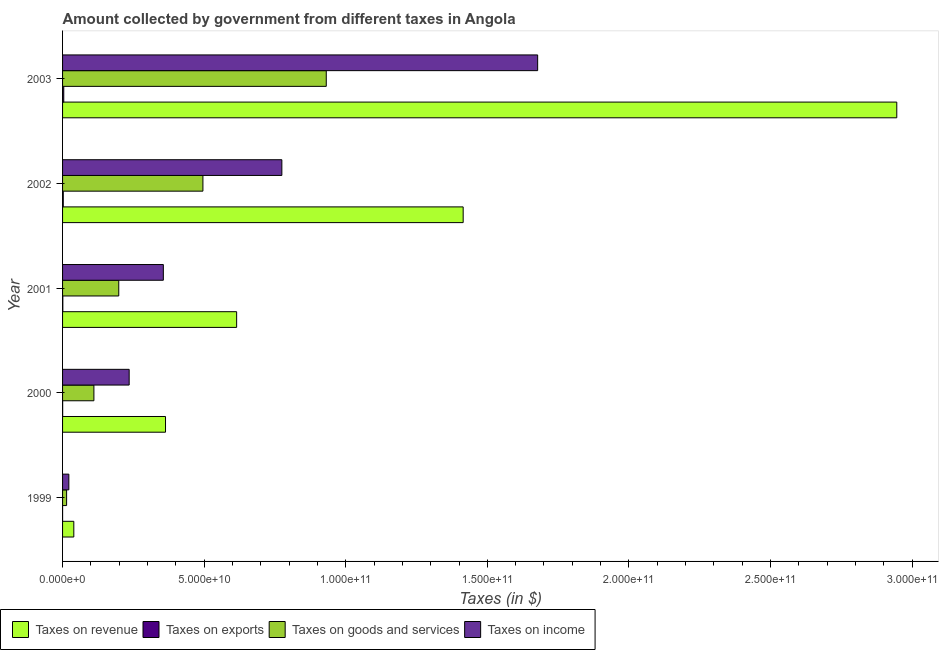How many groups of bars are there?
Make the answer very short. 5. How many bars are there on the 3rd tick from the top?
Your answer should be compact. 4. What is the amount collected as tax on income in 1999?
Ensure brevity in your answer.  2.22e+09. Across all years, what is the maximum amount collected as tax on goods?
Provide a succinct answer. 9.31e+1. Across all years, what is the minimum amount collected as tax on exports?
Provide a short and direct response. 3.22e+06. In which year was the amount collected as tax on revenue maximum?
Your response must be concise. 2003. In which year was the amount collected as tax on revenue minimum?
Your response must be concise. 1999. What is the total amount collected as tax on exports in the graph?
Offer a very short reply. 8.01e+08. What is the difference between the amount collected as tax on goods in 2000 and that in 2003?
Give a very brief answer. -8.21e+1. What is the difference between the amount collected as tax on exports in 2003 and the amount collected as tax on income in 2001?
Your answer should be very brief. -3.52e+1. What is the average amount collected as tax on goods per year?
Provide a short and direct response. 3.50e+1. In the year 1999, what is the difference between the amount collected as tax on revenue and amount collected as tax on income?
Your answer should be compact. 1.75e+09. What is the ratio of the amount collected as tax on income in 2001 to that in 2003?
Offer a very short reply. 0.21. Is the amount collected as tax on income in 1999 less than that in 2000?
Your response must be concise. Yes. What is the difference between the highest and the second highest amount collected as tax on exports?
Give a very brief answer. 1.75e+08. What is the difference between the highest and the lowest amount collected as tax on exports?
Your answer should be very brief. 4.20e+08. In how many years, is the amount collected as tax on goods greater than the average amount collected as tax on goods taken over all years?
Ensure brevity in your answer.  2. Is the sum of the amount collected as tax on revenue in 2000 and 2003 greater than the maximum amount collected as tax on goods across all years?
Ensure brevity in your answer.  Yes. Is it the case that in every year, the sum of the amount collected as tax on revenue and amount collected as tax on exports is greater than the sum of amount collected as tax on income and amount collected as tax on goods?
Your answer should be compact. No. What does the 2nd bar from the top in 2001 represents?
Make the answer very short. Taxes on goods and services. What does the 4th bar from the bottom in 2003 represents?
Give a very brief answer. Taxes on income. Is it the case that in every year, the sum of the amount collected as tax on revenue and amount collected as tax on exports is greater than the amount collected as tax on goods?
Your answer should be very brief. Yes. How many bars are there?
Ensure brevity in your answer.  20. Does the graph contain any zero values?
Your answer should be compact. No. Does the graph contain grids?
Your answer should be very brief. No. Where does the legend appear in the graph?
Your response must be concise. Bottom left. How many legend labels are there?
Make the answer very short. 4. What is the title of the graph?
Ensure brevity in your answer.  Amount collected by government from different taxes in Angola. What is the label or title of the X-axis?
Give a very brief answer. Taxes (in $). What is the Taxes (in $) in Taxes on revenue in 1999?
Offer a very short reply. 3.97e+09. What is the Taxes (in $) in Taxes on exports in 1999?
Your response must be concise. 3.22e+06. What is the Taxes (in $) of Taxes on goods and services in 1999?
Offer a terse response. 1.43e+09. What is the Taxes (in $) in Taxes on income in 1999?
Provide a short and direct response. 2.22e+09. What is the Taxes (in $) in Taxes on revenue in 2000?
Keep it short and to the point. 3.64e+1. What is the Taxes (in $) in Taxes on exports in 2000?
Offer a very short reply. 3.43e+07. What is the Taxes (in $) of Taxes on goods and services in 2000?
Offer a very short reply. 1.11e+1. What is the Taxes (in $) of Taxes on income in 2000?
Provide a succinct answer. 2.35e+1. What is the Taxes (in $) of Taxes on revenue in 2001?
Your answer should be compact. 6.15e+1. What is the Taxes (in $) of Taxes on exports in 2001?
Offer a very short reply. 9.21e+07. What is the Taxes (in $) of Taxes on goods and services in 2001?
Your answer should be very brief. 1.98e+1. What is the Taxes (in $) in Taxes on income in 2001?
Provide a short and direct response. 3.56e+1. What is the Taxes (in $) in Taxes on revenue in 2002?
Keep it short and to the point. 1.41e+11. What is the Taxes (in $) in Taxes on exports in 2002?
Your answer should be compact. 2.48e+08. What is the Taxes (in $) in Taxes on goods and services in 2002?
Your answer should be compact. 4.96e+1. What is the Taxes (in $) of Taxes on income in 2002?
Offer a very short reply. 7.74e+1. What is the Taxes (in $) in Taxes on revenue in 2003?
Give a very brief answer. 2.95e+11. What is the Taxes (in $) in Taxes on exports in 2003?
Offer a terse response. 4.24e+08. What is the Taxes (in $) in Taxes on goods and services in 2003?
Provide a short and direct response. 9.31e+1. What is the Taxes (in $) of Taxes on income in 2003?
Make the answer very short. 1.68e+11. Across all years, what is the maximum Taxes (in $) in Taxes on revenue?
Offer a very short reply. 2.95e+11. Across all years, what is the maximum Taxes (in $) in Taxes on exports?
Your answer should be very brief. 4.24e+08. Across all years, what is the maximum Taxes (in $) in Taxes on goods and services?
Give a very brief answer. 9.31e+1. Across all years, what is the maximum Taxes (in $) of Taxes on income?
Offer a terse response. 1.68e+11. Across all years, what is the minimum Taxes (in $) of Taxes on revenue?
Keep it short and to the point. 3.97e+09. Across all years, what is the minimum Taxes (in $) in Taxes on exports?
Provide a short and direct response. 3.22e+06. Across all years, what is the minimum Taxes (in $) in Taxes on goods and services?
Your answer should be very brief. 1.43e+09. Across all years, what is the minimum Taxes (in $) in Taxes on income?
Make the answer very short. 2.22e+09. What is the total Taxes (in $) in Taxes on revenue in the graph?
Your response must be concise. 5.38e+11. What is the total Taxes (in $) of Taxes on exports in the graph?
Provide a succinct answer. 8.01e+08. What is the total Taxes (in $) of Taxes on goods and services in the graph?
Provide a short and direct response. 1.75e+11. What is the total Taxes (in $) in Taxes on income in the graph?
Make the answer very short. 3.07e+11. What is the difference between the Taxes (in $) in Taxes on revenue in 1999 and that in 2000?
Provide a succinct answer. -3.24e+1. What is the difference between the Taxes (in $) in Taxes on exports in 1999 and that in 2000?
Offer a terse response. -3.10e+07. What is the difference between the Taxes (in $) of Taxes on goods and services in 1999 and that in 2000?
Your answer should be compact. -9.64e+09. What is the difference between the Taxes (in $) of Taxes on income in 1999 and that in 2000?
Make the answer very short. -2.13e+1. What is the difference between the Taxes (in $) in Taxes on revenue in 1999 and that in 2001?
Keep it short and to the point. -5.75e+1. What is the difference between the Taxes (in $) in Taxes on exports in 1999 and that in 2001?
Your response must be concise. -8.88e+07. What is the difference between the Taxes (in $) in Taxes on goods and services in 1999 and that in 2001?
Your response must be concise. -1.84e+1. What is the difference between the Taxes (in $) in Taxes on income in 1999 and that in 2001?
Keep it short and to the point. -3.34e+1. What is the difference between the Taxes (in $) of Taxes on revenue in 1999 and that in 2002?
Provide a succinct answer. -1.38e+11. What is the difference between the Taxes (in $) in Taxes on exports in 1999 and that in 2002?
Offer a very short reply. -2.45e+08. What is the difference between the Taxes (in $) of Taxes on goods and services in 1999 and that in 2002?
Give a very brief answer. -4.81e+1. What is the difference between the Taxes (in $) of Taxes on income in 1999 and that in 2002?
Offer a very short reply. -7.52e+1. What is the difference between the Taxes (in $) in Taxes on revenue in 1999 and that in 2003?
Your response must be concise. -2.91e+11. What is the difference between the Taxes (in $) of Taxes on exports in 1999 and that in 2003?
Give a very brief answer. -4.20e+08. What is the difference between the Taxes (in $) in Taxes on goods and services in 1999 and that in 2003?
Offer a terse response. -9.17e+1. What is the difference between the Taxes (in $) in Taxes on income in 1999 and that in 2003?
Make the answer very short. -1.66e+11. What is the difference between the Taxes (in $) in Taxes on revenue in 2000 and that in 2001?
Keep it short and to the point. -2.51e+1. What is the difference between the Taxes (in $) in Taxes on exports in 2000 and that in 2001?
Your answer should be very brief. -5.78e+07. What is the difference between the Taxes (in $) in Taxes on goods and services in 2000 and that in 2001?
Offer a very short reply. -8.78e+09. What is the difference between the Taxes (in $) of Taxes on income in 2000 and that in 2001?
Your answer should be very brief. -1.21e+1. What is the difference between the Taxes (in $) in Taxes on revenue in 2000 and that in 2002?
Make the answer very short. -1.05e+11. What is the difference between the Taxes (in $) in Taxes on exports in 2000 and that in 2002?
Offer a very short reply. -2.14e+08. What is the difference between the Taxes (in $) in Taxes on goods and services in 2000 and that in 2002?
Ensure brevity in your answer.  -3.85e+1. What is the difference between the Taxes (in $) of Taxes on income in 2000 and that in 2002?
Provide a short and direct response. -5.39e+1. What is the difference between the Taxes (in $) in Taxes on revenue in 2000 and that in 2003?
Ensure brevity in your answer.  -2.58e+11. What is the difference between the Taxes (in $) of Taxes on exports in 2000 and that in 2003?
Your answer should be compact. -3.89e+08. What is the difference between the Taxes (in $) in Taxes on goods and services in 2000 and that in 2003?
Ensure brevity in your answer.  -8.21e+1. What is the difference between the Taxes (in $) in Taxes on income in 2000 and that in 2003?
Offer a very short reply. -1.44e+11. What is the difference between the Taxes (in $) of Taxes on revenue in 2001 and that in 2002?
Make the answer very short. -8.00e+1. What is the difference between the Taxes (in $) in Taxes on exports in 2001 and that in 2002?
Your answer should be very brief. -1.56e+08. What is the difference between the Taxes (in $) in Taxes on goods and services in 2001 and that in 2002?
Give a very brief answer. -2.97e+1. What is the difference between the Taxes (in $) in Taxes on income in 2001 and that in 2002?
Keep it short and to the point. -4.19e+1. What is the difference between the Taxes (in $) of Taxes on revenue in 2001 and that in 2003?
Ensure brevity in your answer.  -2.33e+11. What is the difference between the Taxes (in $) of Taxes on exports in 2001 and that in 2003?
Give a very brief answer. -3.32e+08. What is the difference between the Taxes (in $) in Taxes on goods and services in 2001 and that in 2003?
Your answer should be very brief. -7.33e+1. What is the difference between the Taxes (in $) of Taxes on income in 2001 and that in 2003?
Your response must be concise. -1.32e+11. What is the difference between the Taxes (in $) in Taxes on revenue in 2002 and that in 2003?
Make the answer very short. -1.53e+11. What is the difference between the Taxes (in $) in Taxes on exports in 2002 and that in 2003?
Your answer should be compact. -1.75e+08. What is the difference between the Taxes (in $) in Taxes on goods and services in 2002 and that in 2003?
Give a very brief answer. -4.36e+1. What is the difference between the Taxes (in $) in Taxes on income in 2002 and that in 2003?
Offer a very short reply. -9.03e+1. What is the difference between the Taxes (in $) in Taxes on revenue in 1999 and the Taxes (in $) in Taxes on exports in 2000?
Offer a very short reply. 3.94e+09. What is the difference between the Taxes (in $) of Taxes on revenue in 1999 and the Taxes (in $) of Taxes on goods and services in 2000?
Ensure brevity in your answer.  -7.10e+09. What is the difference between the Taxes (in $) in Taxes on revenue in 1999 and the Taxes (in $) in Taxes on income in 2000?
Keep it short and to the point. -1.96e+1. What is the difference between the Taxes (in $) of Taxes on exports in 1999 and the Taxes (in $) of Taxes on goods and services in 2000?
Offer a very short reply. -1.11e+1. What is the difference between the Taxes (in $) in Taxes on exports in 1999 and the Taxes (in $) in Taxes on income in 2000?
Ensure brevity in your answer.  -2.35e+1. What is the difference between the Taxes (in $) of Taxes on goods and services in 1999 and the Taxes (in $) of Taxes on income in 2000?
Provide a succinct answer. -2.21e+1. What is the difference between the Taxes (in $) in Taxes on revenue in 1999 and the Taxes (in $) in Taxes on exports in 2001?
Your answer should be compact. 3.88e+09. What is the difference between the Taxes (in $) in Taxes on revenue in 1999 and the Taxes (in $) in Taxes on goods and services in 2001?
Your answer should be compact. -1.59e+1. What is the difference between the Taxes (in $) in Taxes on revenue in 1999 and the Taxes (in $) in Taxes on income in 2001?
Provide a succinct answer. -3.16e+1. What is the difference between the Taxes (in $) of Taxes on exports in 1999 and the Taxes (in $) of Taxes on goods and services in 2001?
Your answer should be compact. -1.98e+1. What is the difference between the Taxes (in $) in Taxes on exports in 1999 and the Taxes (in $) in Taxes on income in 2001?
Your answer should be compact. -3.56e+1. What is the difference between the Taxes (in $) of Taxes on goods and services in 1999 and the Taxes (in $) of Taxes on income in 2001?
Provide a succinct answer. -3.42e+1. What is the difference between the Taxes (in $) of Taxes on revenue in 1999 and the Taxes (in $) of Taxes on exports in 2002?
Keep it short and to the point. 3.72e+09. What is the difference between the Taxes (in $) of Taxes on revenue in 1999 and the Taxes (in $) of Taxes on goods and services in 2002?
Offer a very short reply. -4.56e+1. What is the difference between the Taxes (in $) of Taxes on revenue in 1999 and the Taxes (in $) of Taxes on income in 2002?
Provide a short and direct response. -7.35e+1. What is the difference between the Taxes (in $) in Taxes on exports in 1999 and the Taxes (in $) in Taxes on goods and services in 2002?
Ensure brevity in your answer.  -4.96e+1. What is the difference between the Taxes (in $) in Taxes on exports in 1999 and the Taxes (in $) in Taxes on income in 2002?
Your answer should be very brief. -7.74e+1. What is the difference between the Taxes (in $) in Taxes on goods and services in 1999 and the Taxes (in $) in Taxes on income in 2002?
Offer a very short reply. -7.60e+1. What is the difference between the Taxes (in $) of Taxes on revenue in 1999 and the Taxes (in $) of Taxes on exports in 2003?
Offer a terse response. 3.55e+09. What is the difference between the Taxes (in $) of Taxes on revenue in 1999 and the Taxes (in $) of Taxes on goods and services in 2003?
Give a very brief answer. -8.92e+1. What is the difference between the Taxes (in $) in Taxes on revenue in 1999 and the Taxes (in $) in Taxes on income in 2003?
Make the answer very short. -1.64e+11. What is the difference between the Taxes (in $) of Taxes on exports in 1999 and the Taxes (in $) of Taxes on goods and services in 2003?
Keep it short and to the point. -9.31e+1. What is the difference between the Taxes (in $) of Taxes on exports in 1999 and the Taxes (in $) of Taxes on income in 2003?
Provide a short and direct response. -1.68e+11. What is the difference between the Taxes (in $) in Taxes on goods and services in 1999 and the Taxes (in $) in Taxes on income in 2003?
Provide a succinct answer. -1.66e+11. What is the difference between the Taxes (in $) in Taxes on revenue in 2000 and the Taxes (in $) in Taxes on exports in 2001?
Your answer should be compact. 3.63e+1. What is the difference between the Taxes (in $) of Taxes on revenue in 2000 and the Taxes (in $) of Taxes on goods and services in 2001?
Offer a very short reply. 1.65e+1. What is the difference between the Taxes (in $) in Taxes on revenue in 2000 and the Taxes (in $) in Taxes on income in 2001?
Your answer should be compact. 7.67e+08. What is the difference between the Taxes (in $) of Taxes on exports in 2000 and the Taxes (in $) of Taxes on goods and services in 2001?
Give a very brief answer. -1.98e+1. What is the difference between the Taxes (in $) in Taxes on exports in 2000 and the Taxes (in $) in Taxes on income in 2001?
Make the answer very short. -3.56e+1. What is the difference between the Taxes (in $) in Taxes on goods and services in 2000 and the Taxes (in $) in Taxes on income in 2001?
Provide a succinct answer. -2.45e+1. What is the difference between the Taxes (in $) of Taxes on revenue in 2000 and the Taxes (in $) of Taxes on exports in 2002?
Provide a short and direct response. 3.61e+1. What is the difference between the Taxes (in $) in Taxes on revenue in 2000 and the Taxes (in $) in Taxes on goods and services in 2002?
Your answer should be very brief. -1.32e+1. What is the difference between the Taxes (in $) of Taxes on revenue in 2000 and the Taxes (in $) of Taxes on income in 2002?
Make the answer very short. -4.11e+1. What is the difference between the Taxes (in $) in Taxes on exports in 2000 and the Taxes (in $) in Taxes on goods and services in 2002?
Provide a short and direct response. -4.95e+1. What is the difference between the Taxes (in $) in Taxes on exports in 2000 and the Taxes (in $) in Taxes on income in 2002?
Your response must be concise. -7.74e+1. What is the difference between the Taxes (in $) of Taxes on goods and services in 2000 and the Taxes (in $) of Taxes on income in 2002?
Offer a very short reply. -6.64e+1. What is the difference between the Taxes (in $) in Taxes on revenue in 2000 and the Taxes (in $) in Taxes on exports in 2003?
Your answer should be very brief. 3.59e+1. What is the difference between the Taxes (in $) of Taxes on revenue in 2000 and the Taxes (in $) of Taxes on goods and services in 2003?
Keep it short and to the point. -5.68e+1. What is the difference between the Taxes (in $) in Taxes on revenue in 2000 and the Taxes (in $) in Taxes on income in 2003?
Give a very brief answer. -1.31e+11. What is the difference between the Taxes (in $) of Taxes on exports in 2000 and the Taxes (in $) of Taxes on goods and services in 2003?
Your answer should be compact. -9.31e+1. What is the difference between the Taxes (in $) in Taxes on exports in 2000 and the Taxes (in $) in Taxes on income in 2003?
Your answer should be compact. -1.68e+11. What is the difference between the Taxes (in $) of Taxes on goods and services in 2000 and the Taxes (in $) of Taxes on income in 2003?
Your answer should be compact. -1.57e+11. What is the difference between the Taxes (in $) of Taxes on revenue in 2001 and the Taxes (in $) of Taxes on exports in 2002?
Offer a terse response. 6.12e+1. What is the difference between the Taxes (in $) of Taxes on revenue in 2001 and the Taxes (in $) of Taxes on goods and services in 2002?
Your answer should be compact. 1.19e+1. What is the difference between the Taxes (in $) of Taxes on revenue in 2001 and the Taxes (in $) of Taxes on income in 2002?
Offer a terse response. -1.60e+1. What is the difference between the Taxes (in $) of Taxes on exports in 2001 and the Taxes (in $) of Taxes on goods and services in 2002?
Give a very brief answer. -4.95e+1. What is the difference between the Taxes (in $) of Taxes on exports in 2001 and the Taxes (in $) of Taxes on income in 2002?
Give a very brief answer. -7.73e+1. What is the difference between the Taxes (in $) of Taxes on goods and services in 2001 and the Taxes (in $) of Taxes on income in 2002?
Ensure brevity in your answer.  -5.76e+1. What is the difference between the Taxes (in $) of Taxes on revenue in 2001 and the Taxes (in $) of Taxes on exports in 2003?
Provide a succinct answer. 6.11e+1. What is the difference between the Taxes (in $) of Taxes on revenue in 2001 and the Taxes (in $) of Taxes on goods and services in 2003?
Make the answer very short. -3.16e+1. What is the difference between the Taxes (in $) in Taxes on revenue in 2001 and the Taxes (in $) in Taxes on income in 2003?
Provide a succinct answer. -1.06e+11. What is the difference between the Taxes (in $) in Taxes on exports in 2001 and the Taxes (in $) in Taxes on goods and services in 2003?
Make the answer very short. -9.30e+1. What is the difference between the Taxes (in $) in Taxes on exports in 2001 and the Taxes (in $) in Taxes on income in 2003?
Keep it short and to the point. -1.68e+11. What is the difference between the Taxes (in $) in Taxes on goods and services in 2001 and the Taxes (in $) in Taxes on income in 2003?
Offer a very short reply. -1.48e+11. What is the difference between the Taxes (in $) of Taxes on revenue in 2002 and the Taxes (in $) of Taxes on exports in 2003?
Your answer should be compact. 1.41e+11. What is the difference between the Taxes (in $) of Taxes on revenue in 2002 and the Taxes (in $) of Taxes on goods and services in 2003?
Offer a terse response. 4.83e+1. What is the difference between the Taxes (in $) in Taxes on revenue in 2002 and the Taxes (in $) in Taxes on income in 2003?
Keep it short and to the point. -2.63e+1. What is the difference between the Taxes (in $) of Taxes on exports in 2002 and the Taxes (in $) of Taxes on goods and services in 2003?
Your answer should be very brief. -9.29e+1. What is the difference between the Taxes (in $) of Taxes on exports in 2002 and the Taxes (in $) of Taxes on income in 2003?
Keep it short and to the point. -1.68e+11. What is the difference between the Taxes (in $) of Taxes on goods and services in 2002 and the Taxes (in $) of Taxes on income in 2003?
Give a very brief answer. -1.18e+11. What is the average Taxes (in $) in Taxes on revenue per year?
Provide a short and direct response. 1.08e+11. What is the average Taxes (in $) of Taxes on exports per year?
Make the answer very short. 1.60e+08. What is the average Taxes (in $) of Taxes on goods and services per year?
Your answer should be compact. 3.50e+1. What is the average Taxes (in $) in Taxes on income per year?
Keep it short and to the point. 6.13e+1. In the year 1999, what is the difference between the Taxes (in $) in Taxes on revenue and Taxes (in $) in Taxes on exports?
Offer a terse response. 3.97e+09. In the year 1999, what is the difference between the Taxes (in $) in Taxes on revenue and Taxes (in $) in Taxes on goods and services?
Offer a very short reply. 2.54e+09. In the year 1999, what is the difference between the Taxes (in $) in Taxes on revenue and Taxes (in $) in Taxes on income?
Provide a succinct answer. 1.75e+09. In the year 1999, what is the difference between the Taxes (in $) in Taxes on exports and Taxes (in $) in Taxes on goods and services?
Offer a terse response. -1.42e+09. In the year 1999, what is the difference between the Taxes (in $) in Taxes on exports and Taxes (in $) in Taxes on income?
Ensure brevity in your answer.  -2.22e+09. In the year 1999, what is the difference between the Taxes (in $) of Taxes on goods and services and Taxes (in $) of Taxes on income?
Offer a terse response. -7.93e+08. In the year 2000, what is the difference between the Taxes (in $) of Taxes on revenue and Taxes (in $) of Taxes on exports?
Provide a short and direct response. 3.63e+1. In the year 2000, what is the difference between the Taxes (in $) of Taxes on revenue and Taxes (in $) of Taxes on goods and services?
Give a very brief answer. 2.53e+1. In the year 2000, what is the difference between the Taxes (in $) of Taxes on revenue and Taxes (in $) of Taxes on income?
Your response must be concise. 1.28e+1. In the year 2000, what is the difference between the Taxes (in $) in Taxes on exports and Taxes (in $) in Taxes on goods and services?
Give a very brief answer. -1.10e+1. In the year 2000, what is the difference between the Taxes (in $) in Taxes on exports and Taxes (in $) in Taxes on income?
Offer a terse response. -2.35e+1. In the year 2000, what is the difference between the Taxes (in $) of Taxes on goods and services and Taxes (in $) of Taxes on income?
Provide a short and direct response. -1.25e+1. In the year 2001, what is the difference between the Taxes (in $) in Taxes on revenue and Taxes (in $) in Taxes on exports?
Ensure brevity in your answer.  6.14e+1. In the year 2001, what is the difference between the Taxes (in $) of Taxes on revenue and Taxes (in $) of Taxes on goods and services?
Provide a short and direct response. 4.16e+1. In the year 2001, what is the difference between the Taxes (in $) in Taxes on revenue and Taxes (in $) in Taxes on income?
Keep it short and to the point. 2.59e+1. In the year 2001, what is the difference between the Taxes (in $) of Taxes on exports and Taxes (in $) of Taxes on goods and services?
Ensure brevity in your answer.  -1.98e+1. In the year 2001, what is the difference between the Taxes (in $) in Taxes on exports and Taxes (in $) in Taxes on income?
Give a very brief answer. -3.55e+1. In the year 2001, what is the difference between the Taxes (in $) of Taxes on goods and services and Taxes (in $) of Taxes on income?
Give a very brief answer. -1.57e+1. In the year 2002, what is the difference between the Taxes (in $) in Taxes on revenue and Taxes (in $) in Taxes on exports?
Offer a terse response. 1.41e+11. In the year 2002, what is the difference between the Taxes (in $) of Taxes on revenue and Taxes (in $) of Taxes on goods and services?
Make the answer very short. 9.19e+1. In the year 2002, what is the difference between the Taxes (in $) in Taxes on revenue and Taxes (in $) in Taxes on income?
Provide a succinct answer. 6.40e+1. In the year 2002, what is the difference between the Taxes (in $) in Taxes on exports and Taxes (in $) in Taxes on goods and services?
Your answer should be compact. -4.93e+1. In the year 2002, what is the difference between the Taxes (in $) of Taxes on exports and Taxes (in $) of Taxes on income?
Ensure brevity in your answer.  -7.72e+1. In the year 2002, what is the difference between the Taxes (in $) in Taxes on goods and services and Taxes (in $) in Taxes on income?
Provide a succinct answer. -2.79e+1. In the year 2003, what is the difference between the Taxes (in $) of Taxes on revenue and Taxes (in $) of Taxes on exports?
Make the answer very short. 2.94e+11. In the year 2003, what is the difference between the Taxes (in $) in Taxes on revenue and Taxes (in $) in Taxes on goods and services?
Make the answer very short. 2.01e+11. In the year 2003, what is the difference between the Taxes (in $) of Taxes on revenue and Taxes (in $) of Taxes on income?
Make the answer very short. 1.27e+11. In the year 2003, what is the difference between the Taxes (in $) in Taxes on exports and Taxes (in $) in Taxes on goods and services?
Offer a very short reply. -9.27e+1. In the year 2003, what is the difference between the Taxes (in $) in Taxes on exports and Taxes (in $) in Taxes on income?
Provide a short and direct response. -1.67e+11. In the year 2003, what is the difference between the Taxes (in $) of Taxes on goods and services and Taxes (in $) of Taxes on income?
Your response must be concise. -7.46e+1. What is the ratio of the Taxes (in $) in Taxes on revenue in 1999 to that in 2000?
Offer a very short reply. 0.11. What is the ratio of the Taxes (in $) in Taxes on exports in 1999 to that in 2000?
Make the answer very short. 0.09. What is the ratio of the Taxes (in $) in Taxes on goods and services in 1999 to that in 2000?
Make the answer very short. 0.13. What is the ratio of the Taxes (in $) of Taxes on income in 1999 to that in 2000?
Offer a very short reply. 0.09. What is the ratio of the Taxes (in $) of Taxes on revenue in 1999 to that in 2001?
Your answer should be compact. 0.06. What is the ratio of the Taxes (in $) in Taxes on exports in 1999 to that in 2001?
Offer a terse response. 0.04. What is the ratio of the Taxes (in $) of Taxes on goods and services in 1999 to that in 2001?
Make the answer very short. 0.07. What is the ratio of the Taxes (in $) in Taxes on income in 1999 to that in 2001?
Your answer should be compact. 0.06. What is the ratio of the Taxes (in $) in Taxes on revenue in 1999 to that in 2002?
Make the answer very short. 0.03. What is the ratio of the Taxes (in $) in Taxes on exports in 1999 to that in 2002?
Keep it short and to the point. 0.01. What is the ratio of the Taxes (in $) in Taxes on goods and services in 1999 to that in 2002?
Keep it short and to the point. 0.03. What is the ratio of the Taxes (in $) of Taxes on income in 1999 to that in 2002?
Give a very brief answer. 0.03. What is the ratio of the Taxes (in $) in Taxes on revenue in 1999 to that in 2003?
Your answer should be compact. 0.01. What is the ratio of the Taxes (in $) in Taxes on exports in 1999 to that in 2003?
Offer a terse response. 0.01. What is the ratio of the Taxes (in $) of Taxes on goods and services in 1999 to that in 2003?
Offer a very short reply. 0.02. What is the ratio of the Taxes (in $) of Taxes on income in 1999 to that in 2003?
Give a very brief answer. 0.01. What is the ratio of the Taxes (in $) in Taxes on revenue in 2000 to that in 2001?
Keep it short and to the point. 0.59. What is the ratio of the Taxes (in $) of Taxes on exports in 2000 to that in 2001?
Your answer should be compact. 0.37. What is the ratio of the Taxes (in $) in Taxes on goods and services in 2000 to that in 2001?
Give a very brief answer. 0.56. What is the ratio of the Taxes (in $) in Taxes on income in 2000 to that in 2001?
Make the answer very short. 0.66. What is the ratio of the Taxes (in $) of Taxes on revenue in 2000 to that in 2002?
Give a very brief answer. 0.26. What is the ratio of the Taxes (in $) in Taxes on exports in 2000 to that in 2002?
Your response must be concise. 0.14. What is the ratio of the Taxes (in $) of Taxes on goods and services in 2000 to that in 2002?
Make the answer very short. 0.22. What is the ratio of the Taxes (in $) of Taxes on income in 2000 to that in 2002?
Your answer should be compact. 0.3. What is the ratio of the Taxes (in $) of Taxes on revenue in 2000 to that in 2003?
Offer a very short reply. 0.12. What is the ratio of the Taxes (in $) of Taxes on exports in 2000 to that in 2003?
Provide a succinct answer. 0.08. What is the ratio of the Taxes (in $) of Taxes on goods and services in 2000 to that in 2003?
Offer a very short reply. 0.12. What is the ratio of the Taxes (in $) in Taxes on income in 2000 to that in 2003?
Provide a succinct answer. 0.14. What is the ratio of the Taxes (in $) in Taxes on revenue in 2001 to that in 2002?
Provide a succinct answer. 0.43. What is the ratio of the Taxes (in $) in Taxes on exports in 2001 to that in 2002?
Make the answer very short. 0.37. What is the ratio of the Taxes (in $) of Taxes on goods and services in 2001 to that in 2002?
Keep it short and to the point. 0.4. What is the ratio of the Taxes (in $) of Taxes on income in 2001 to that in 2002?
Make the answer very short. 0.46. What is the ratio of the Taxes (in $) of Taxes on revenue in 2001 to that in 2003?
Provide a succinct answer. 0.21. What is the ratio of the Taxes (in $) of Taxes on exports in 2001 to that in 2003?
Offer a terse response. 0.22. What is the ratio of the Taxes (in $) in Taxes on goods and services in 2001 to that in 2003?
Make the answer very short. 0.21. What is the ratio of the Taxes (in $) in Taxes on income in 2001 to that in 2003?
Your response must be concise. 0.21. What is the ratio of the Taxes (in $) in Taxes on revenue in 2002 to that in 2003?
Offer a very short reply. 0.48. What is the ratio of the Taxes (in $) in Taxes on exports in 2002 to that in 2003?
Your response must be concise. 0.59. What is the ratio of the Taxes (in $) in Taxes on goods and services in 2002 to that in 2003?
Your answer should be very brief. 0.53. What is the ratio of the Taxes (in $) in Taxes on income in 2002 to that in 2003?
Your answer should be compact. 0.46. What is the difference between the highest and the second highest Taxes (in $) of Taxes on revenue?
Your response must be concise. 1.53e+11. What is the difference between the highest and the second highest Taxes (in $) in Taxes on exports?
Give a very brief answer. 1.75e+08. What is the difference between the highest and the second highest Taxes (in $) of Taxes on goods and services?
Provide a succinct answer. 4.36e+1. What is the difference between the highest and the second highest Taxes (in $) in Taxes on income?
Give a very brief answer. 9.03e+1. What is the difference between the highest and the lowest Taxes (in $) in Taxes on revenue?
Give a very brief answer. 2.91e+11. What is the difference between the highest and the lowest Taxes (in $) of Taxes on exports?
Make the answer very short. 4.20e+08. What is the difference between the highest and the lowest Taxes (in $) of Taxes on goods and services?
Keep it short and to the point. 9.17e+1. What is the difference between the highest and the lowest Taxes (in $) of Taxes on income?
Ensure brevity in your answer.  1.66e+11. 